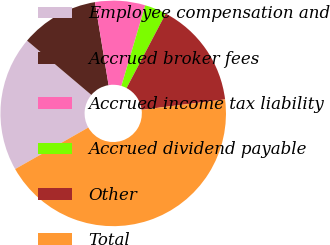Convert chart to OTSL. <chart><loc_0><loc_0><loc_500><loc_500><pie_chart><fcel>Employee compensation and<fcel>Accrued broker fees<fcel>Accrued income tax liability<fcel>Accrued dividend payable<fcel>Other<fcel>Total<nl><fcel>19.38%<fcel>11.25%<fcel>7.18%<fcel>3.12%<fcel>15.31%<fcel>43.77%<nl></chart> 